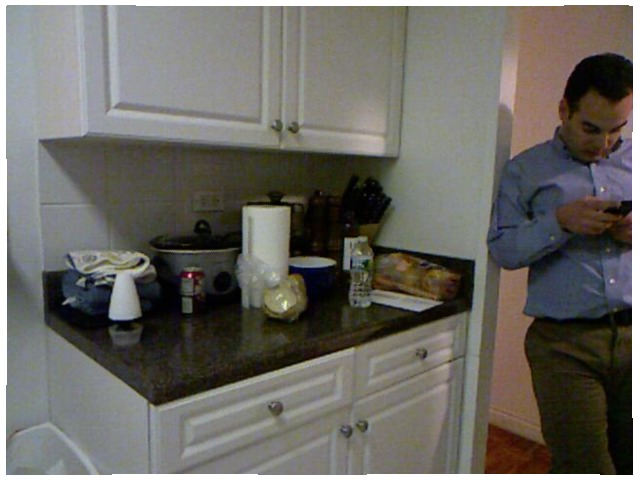<image>
Is there a air freshener on the soda? No. The air freshener is not positioned on the soda. They may be near each other, but the air freshener is not supported by or resting on top of the soda. Is the water bottle behind the man? Yes. From this viewpoint, the water bottle is positioned behind the man, with the man partially or fully occluding the water bottle. 